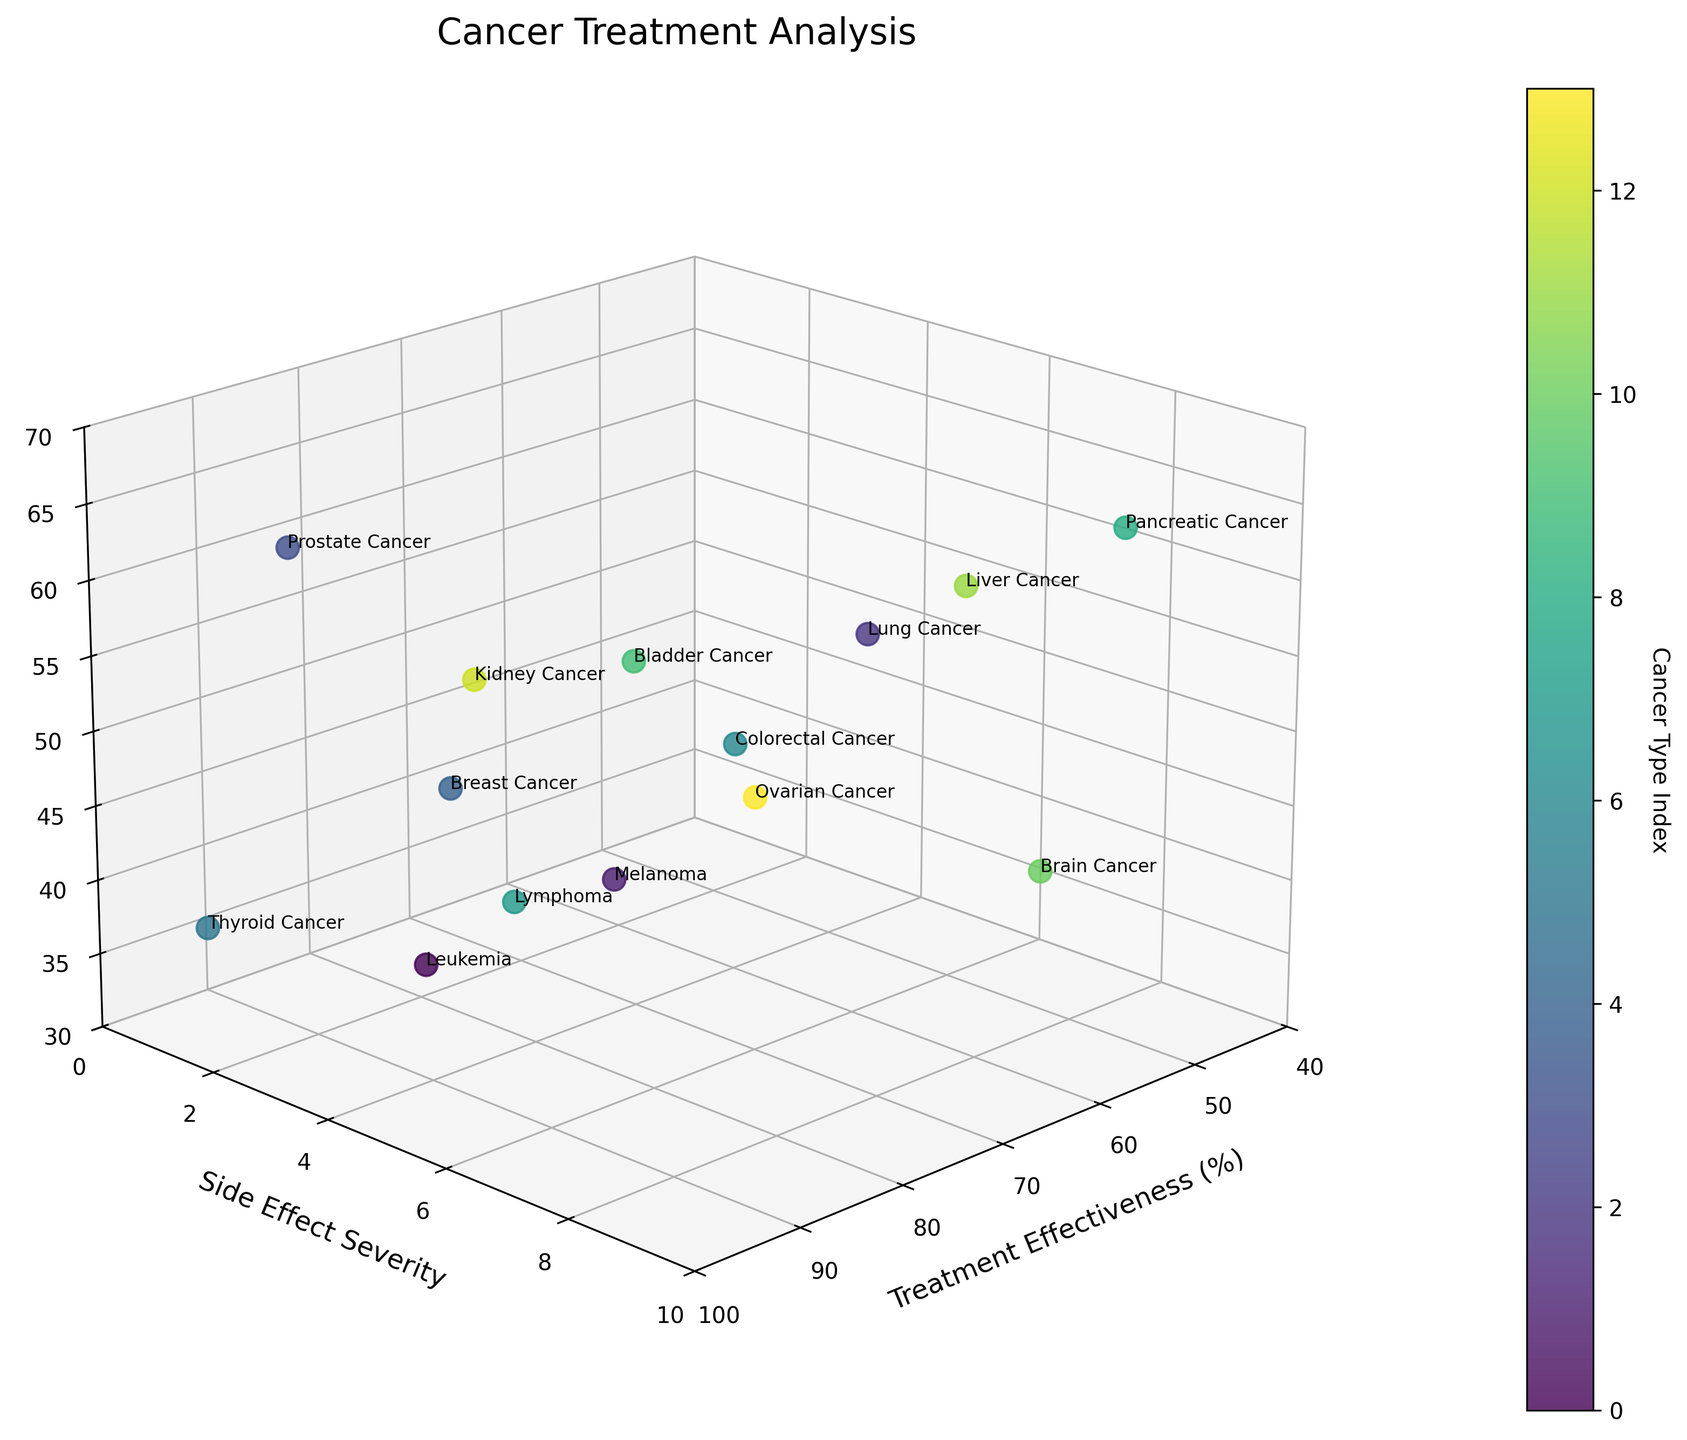What is the title of the figure? The title is displayed at the top center of the figure, which reads "Cancer Treatment Analysis".
Answer: Cancer Treatment Analysis What are the labels of the three axes? The labels are written along each axis. The x-axis is labeled "Treatment Effectiveness (%)", the y-axis is labeled "Side Effect Severity", and the z-axis is labeled "Patient Age".
Answer: Treatment Effectiveness (%), Side Effect Severity, Patient Age How many data points are shown in the figure? Each data point corresponds to an item in the data provided. There are 14 rows in the dataset, so there are 14 data points in the plot.
Answer: 14 What is the treatment effectiveness percentage for Pancreatic Cancer? Go to the Pancreatic Cancer label in the plot and check its position on the Treatment Effectiveness axis. It is at 45%.
Answer: 45% Which cancer type has the highest treatment effectiveness? Look for the highest value on the Treatment Effectiveness axis and find the corresponding cancer label. Thyroid Cancer has the highest value at 95%.
Answer: Thyroid Cancer Which cancer type has the most severe side effects? Look for the cancer type on the plot positioned at the highest value on the Side Effect Severity axis. Brain Cancer shows the most severe side effects with a severity of 9.
Answer: Brain Cancer What is the average patient age across all cancer types represented in the figure? To find the average, sum up the ages of all patients and divide by the number of data points. Sum of ages = 35+42+58+63+49+37+51+40+62+56+44+59+53+47 = 656. Average = 656 / 14 ≈ 46.86.
Answer: 46.86 How does the treatment effectiveness of Melanoma compare to that of Leukemia? Find both Melanoma and Leukemia on the plot and compare their positions on the Treatment Effectiveness axis. Melanoma is at 78% while Leukemia is at 85%, so Leukemia has a higher treatment effectiveness.
Answer: Leukemia has higher treatment effectiveness than Melanoma Compare the side effect severity of Breast Cancer and Bladder Cancer. Locate both Breast Cancer and Bladder Cancer on the plot and compare their positions on the Side Effect Severity axis. Both have a side effect severity of 4 and 5 respectively.
Answer: Bladder Cancer has a higher side effect severity What are the three cancer types with the lowest treatment effectiveness? Identify and list the three points lowest on the Treatment Effectiveness axis. Pancreatic Cancer (45%), Liver Cancer (55%), and Brain Cancer (60%) have the lowest treatment effectiveness.
Answer: Pancreatic Cancer, Liver Cancer, Brain Cancer 